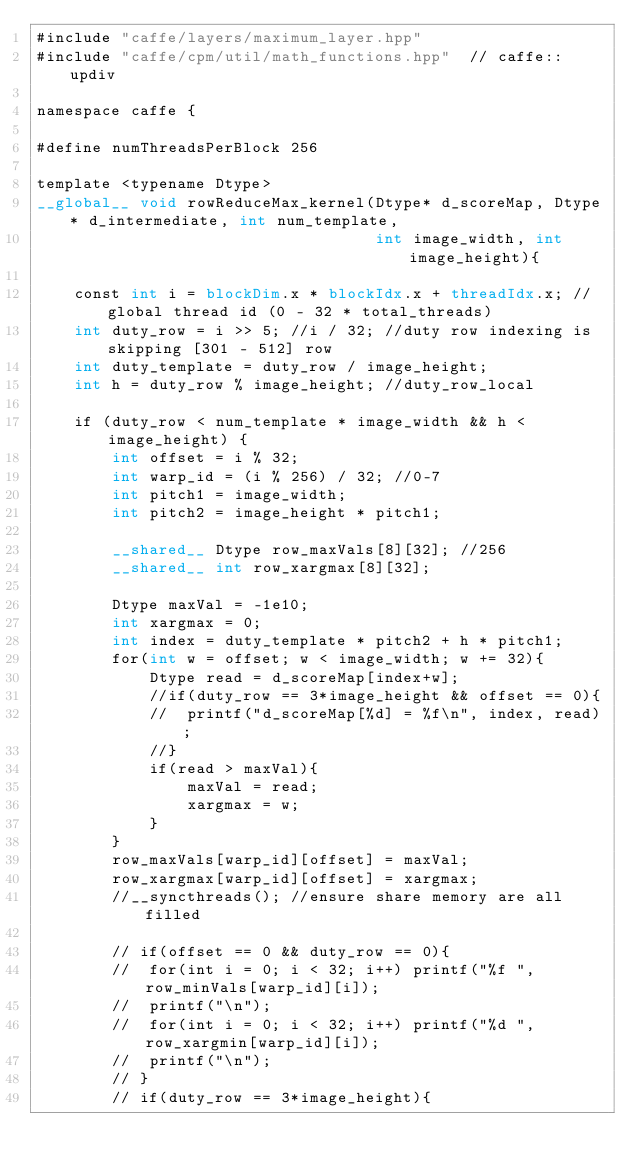<code> <loc_0><loc_0><loc_500><loc_500><_Cuda_>#include "caffe/layers/maximum_layer.hpp"
#include "caffe/cpm/util/math_functions.hpp"  // caffe::updiv

namespace caffe {

#define numThreadsPerBlock 256

template <typename Dtype>
__global__ void rowReduceMax_kernel(Dtype* d_scoreMap, Dtype* d_intermediate, int num_template,
	                                int image_width, int image_height){

	const int i = blockDim.x * blockIdx.x + threadIdx.x; //global thread id (0 - 32 * total_threads)
	int duty_row = i >> 5; //i / 32; //duty row indexing is skipping [301 - 512] row
    int duty_template = duty_row / image_height;
    int h = duty_row % image_height; //duty_row_local

    if (duty_row < num_template * image_width && h < image_height) {
        int offset = i % 32;
	    int warp_id = (i % 256) / 32; //0-7
	    int pitch1 = image_width;
	    int pitch2 = image_height * pitch1;

	    __shared__ Dtype row_maxVals[8][32]; //256
	    __shared__ int row_xargmax[8][32];

	    Dtype maxVal = -1e10;
	    int xargmax = 0;
	    int index = duty_template * pitch2 + h * pitch1;
	    for(int w = offset; w < image_width; w += 32){
	    	Dtype read = d_scoreMap[index+w];
	    	//if(duty_row == 3*image_height && offset == 0){
	    	//	printf("d_scoreMap[%d] = %f\n", index, read);
	    	//}
	    	if(read > maxVal){
	    		maxVal = read;
	    		xargmax = w;
	    	}
	    }
	    row_maxVals[warp_id][offset] = maxVal;
	    row_xargmax[warp_id][offset] = xargmax;
	    //__syncthreads(); //ensure share memory are all filled

	    // if(offset == 0 && duty_row == 0){
	    // 	for(int i = 0; i < 32; i++) printf("%f ", row_minVals[warp_id][i]);
	    // 	printf("\n");
	    // 	for(int i = 0; i < 32; i++) printf("%d ", row_xargmin[warp_id][i]);
	    // 	printf("\n");
	    // }
	    // if(duty_row == 3*image_height){</code> 